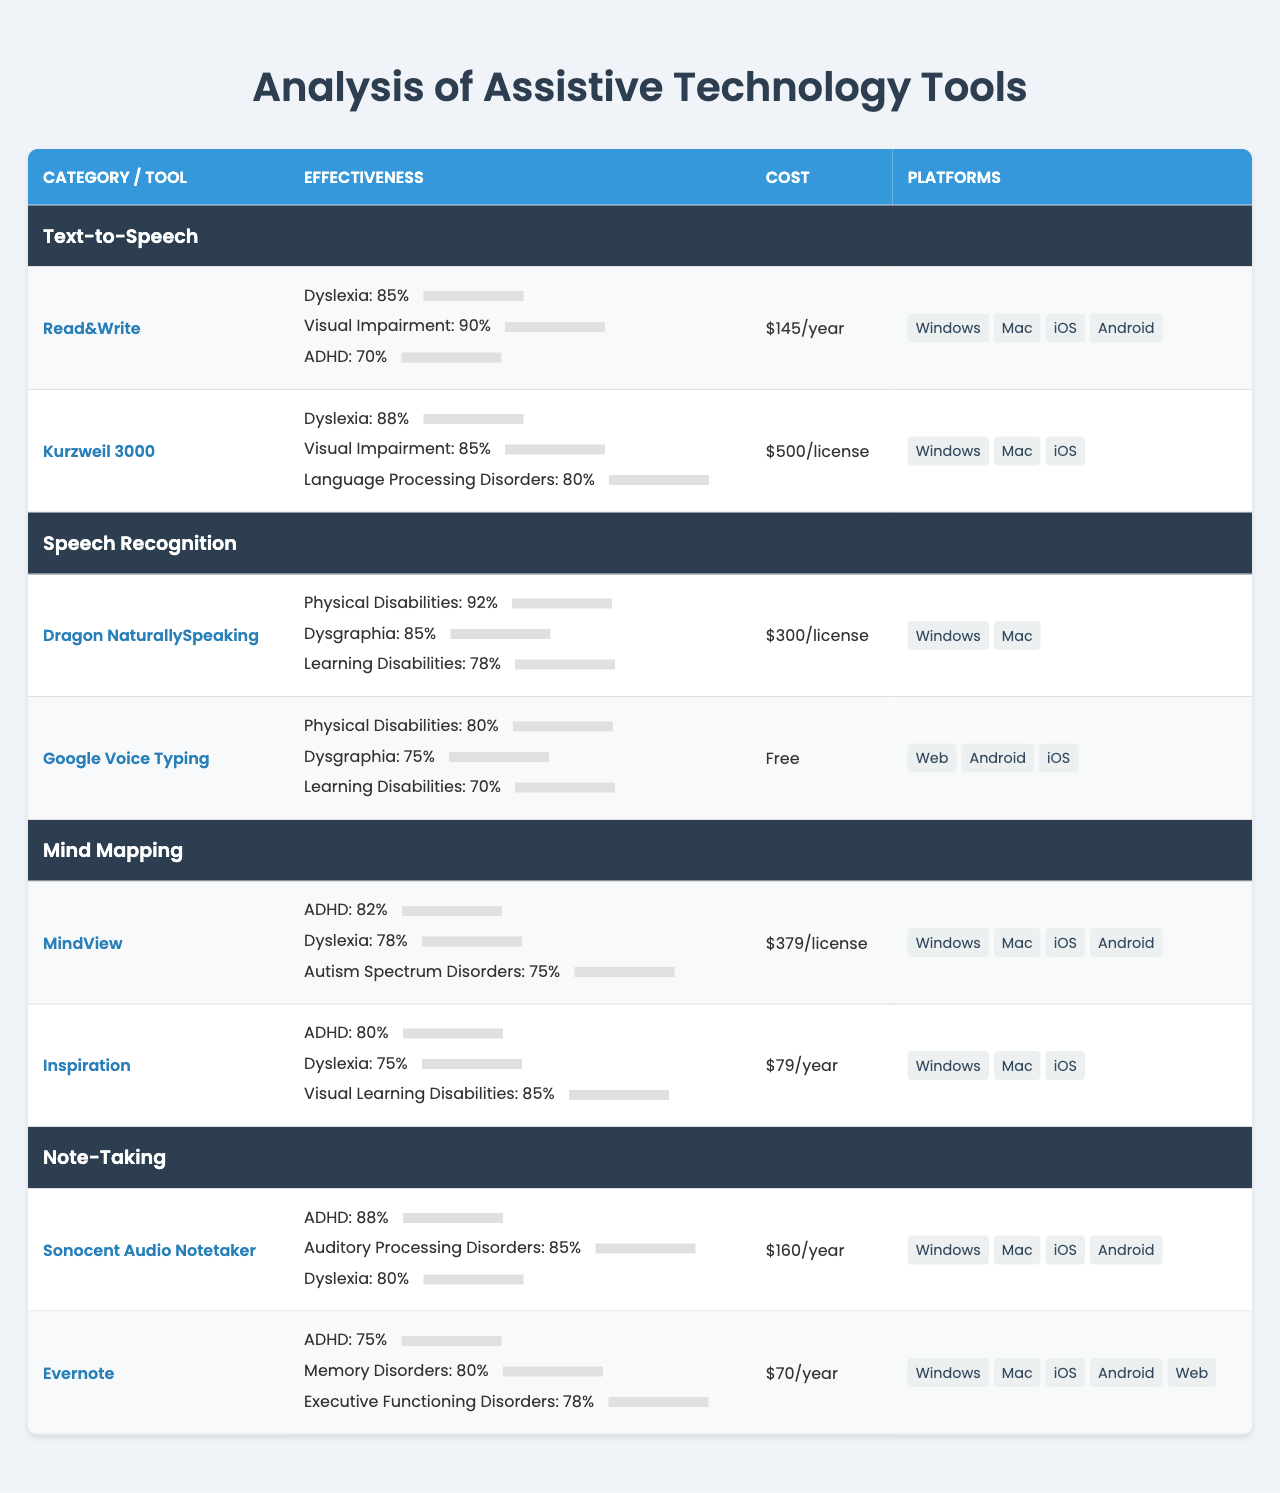What is the effectiveness percentage of Kurzweil 3000 for Dyslexia? The table shows Kurzweil 3000's effectiveness for Dyslexia is listed under its effectiveness section as 88%.
Answer: 88% Which tool has the highest effectiveness for Visual Impairment? Read&Write has the highest effectiveness for Visual Impairment listed at 90%.
Answer: Read&Write What is the cost of MindView? The table indicates that the cost of MindView is $379 per license.
Answer: $379/license How many tools are available for the category "Note-Taking"? In the "Note-Taking" category, there are two tools listed: Sonocent Audio Notetaker and Evernote.
Answer: 2 Is Google Voice Typing effective for Learning Disabilities? The effectiveness percentage for Learning Disabilities under Google Voice Typing is 70%, indicating it is effective but to a lesser extent compared to other tools.
Answer: Yes Which tool has the lowest effectiveness for ADHD? The tool with the lowest effectiveness for ADHD is Evernote, with an effectiveness percentage of 75%.
Answer: Evernote Calculate the average effectiveness for Dyslexia across all tools listed in the table. The effectiveness percentages for Dyslexia are 85% (Read&Write), 88% (Kurzweil 3000), 78% (MindView), and 80% (Sonocent Audio Notetaker). The total is 331%, and the average is 331%/4 = 82.75%.
Answer: 82.75% Which category has the highest cost for its tools? Among all categories, "Text-to-Speech" contains the tool Kurzweil 3000 with a cost of $500/license, which is the highest cost in the table.
Answer: Text-to-Speech Is there any tool that costs less than $100? Yes, Inspiration and Evernote are two tools listed at $79/year and $70/year respectively, both under $100.
Answer: Yes What is the effectiveness percentage for Dragon NaturallySpeaking for Physical Disabilities? The effectiveness for Dragon NaturallySpeaking for Physical Disabilities is shown as 92%.
Answer: 92% What is the total effectiveness percentage for tools under the "Speech Recognition" category for Dysgraphia? The two tools in Speech Recognition are Dragon NaturallySpeaking (85%) and Google Voice Typing (75%). Summing these, the total effectiveness for Dysgraphia in this category is 85% + 75% = 160%.
Answer: 160% 